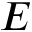Convert formula to latex. <formula><loc_0><loc_0><loc_500><loc_500>E</formula> 